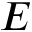Convert formula to latex. <formula><loc_0><loc_0><loc_500><loc_500>E</formula> 